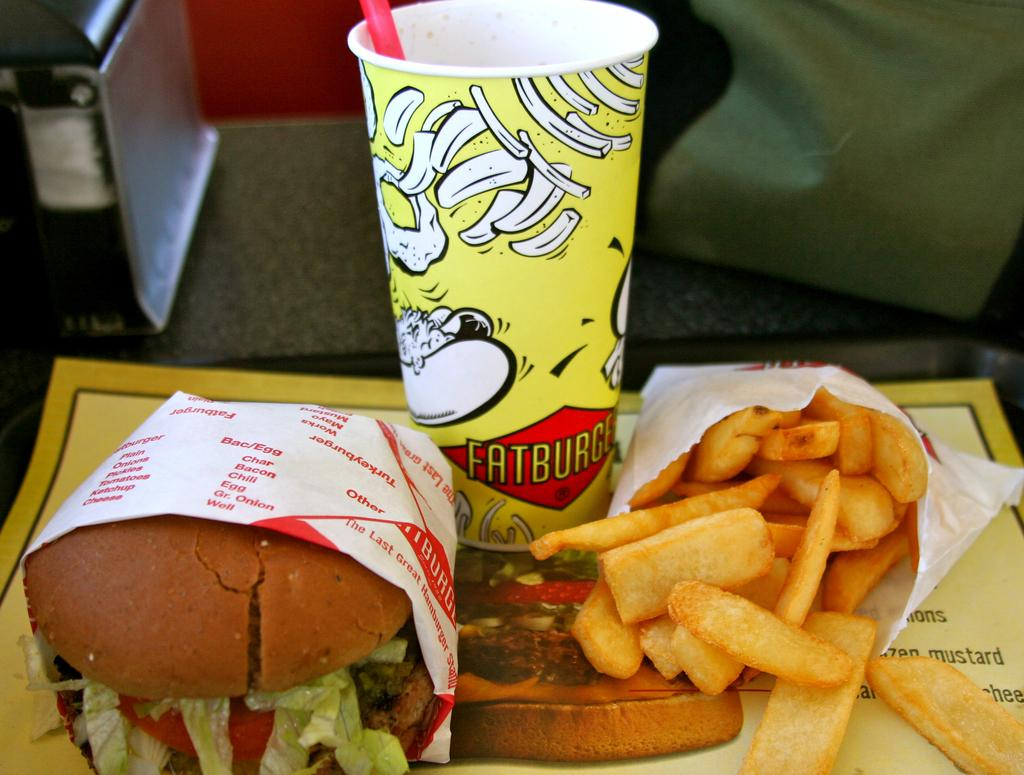What is located at the bottom of the image? There is a table at the bottom of the image. What is on the table in the image? There is food and a cup on the table. Can you describe the background of the image? The background of the image is blurred. Where is the scarecrow located in the image? There is no scarecrow present in the image. What type of books can be seen in the library in the image? There is no library present in the image. 